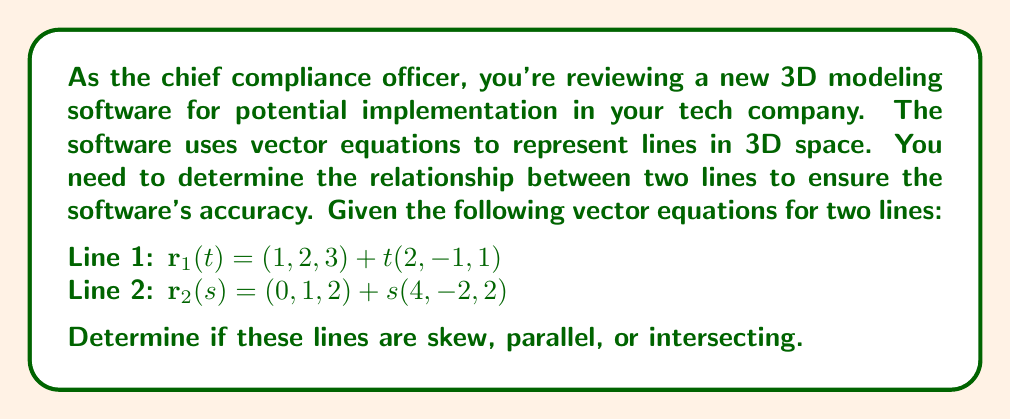Provide a solution to this math problem. To determine the relationship between the two lines, we'll follow these steps:

1. Compare the direction vectors:
   Line 1 direction vector: $\mathbf{v}_1 = (2, -1, 1)$
   Line 2 direction vector: $\mathbf{v}_2 = (4, -2, 2)$

2. Check if the direction vectors are parallel:
   $\mathbf{v}_2 = 2\mathbf{v}_1$, so the direction vectors are parallel.

3. Since the direction vectors are parallel, the lines are either parallel or coincident (intersecting at all points). To determine which, we need to check if there's a point that satisfies both line equations.

4. Set up an equation to find if there's a common point:
   $(1, 2, 3) + t(2, -1, 1) = (0, 1, 2) + s(4, -2, 2)$

5. This gives us three equations:
   $1 + 2t = 0 + 4s$
   $2 - t = 1 - 2s$
   $3 + t = 2 + 2s$

6. Simplify:
   $2t - 4s = -1$
   $t + 2s = 1$
   $t - 2s = 1$

7. From the last two equations:
   $t + 2s = 1$
   $t - 2s = 1$
   
   Subtracting these equations eliminates $t$:
   $4s = 0$
   $s = 0$

8. Substituting $s = 0$ into $t - 2s = 1$:
   $t = 1$

9. Check if $(s, t) = (0, 1)$ satisfies all equations:
   $2(1) - 4(0) = -1 + 2$ (True)
   $1 + 2(0) = 1$ (True)
   $1 - 2(0) = 1$ (True)

Since we found a solution, the lines intersect at a single point.
Answer: The lines are intersecting. 